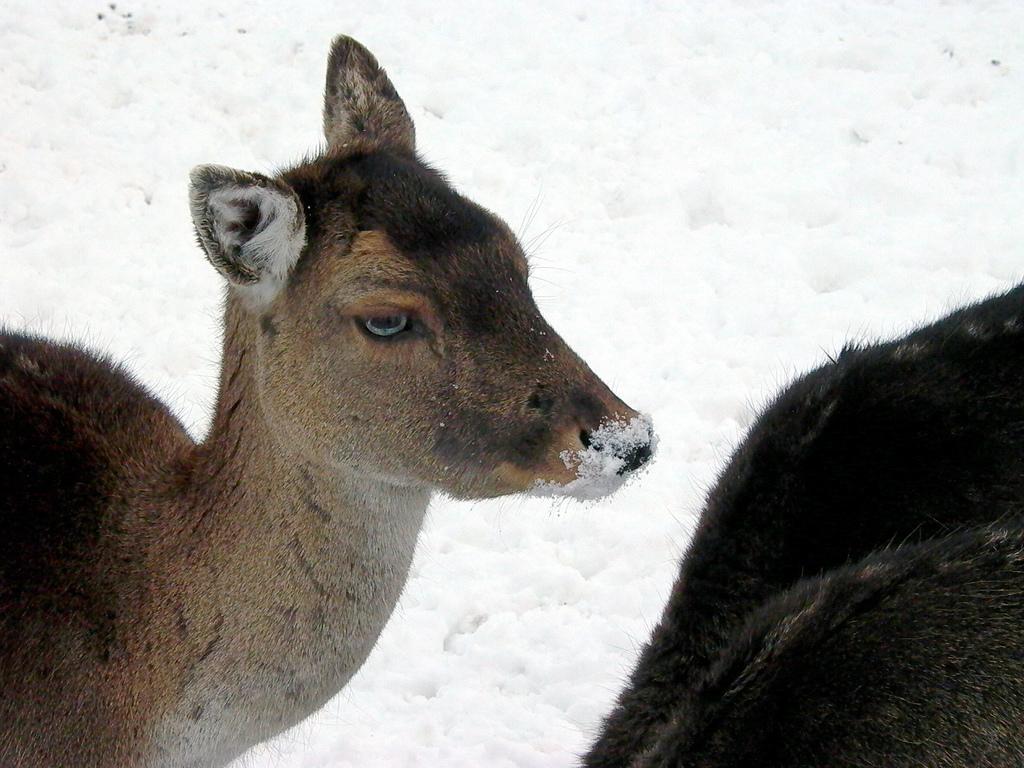Can you describe this image briefly? In the center of the image there is a animal. In the background of the image there is snow. 